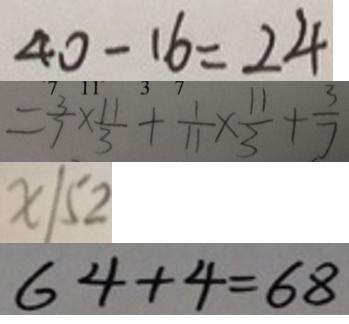<formula> <loc_0><loc_0><loc_500><loc_500>4 0 - 1 6 = 2 4 
 = \frac { 3 } { 7 } \times \frac { 1 1 } { 3 } + \frac { 1 } { 1 1 } \times \frac { 1 1 } { 3 } + \frac { 3 } { 7 } 
 x / 5 2 
 6 4 + 4 = 6 8</formula> 